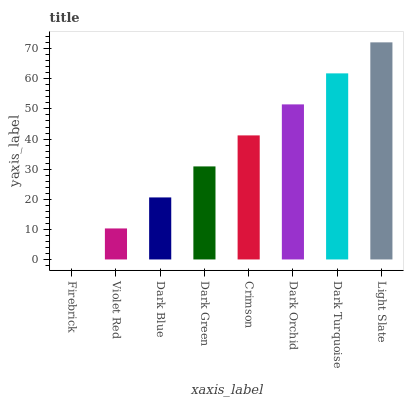Is Firebrick the minimum?
Answer yes or no. Yes. Is Light Slate the maximum?
Answer yes or no. Yes. Is Violet Red the minimum?
Answer yes or no. No. Is Violet Red the maximum?
Answer yes or no. No. Is Violet Red greater than Firebrick?
Answer yes or no. Yes. Is Firebrick less than Violet Red?
Answer yes or no. Yes. Is Firebrick greater than Violet Red?
Answer yes or no. No. Is Violet Red less than Firebrick?
Answer yes or no. No. Is Crimson the high median?
Answer yes or no. Yes. Is Dark Green the low median?
Answer yes or no. Yes. Is Dark Orchid the high median?
Answer yes or no. No. Is Dark Turquoise the low median?
Answer yes or no. No. 